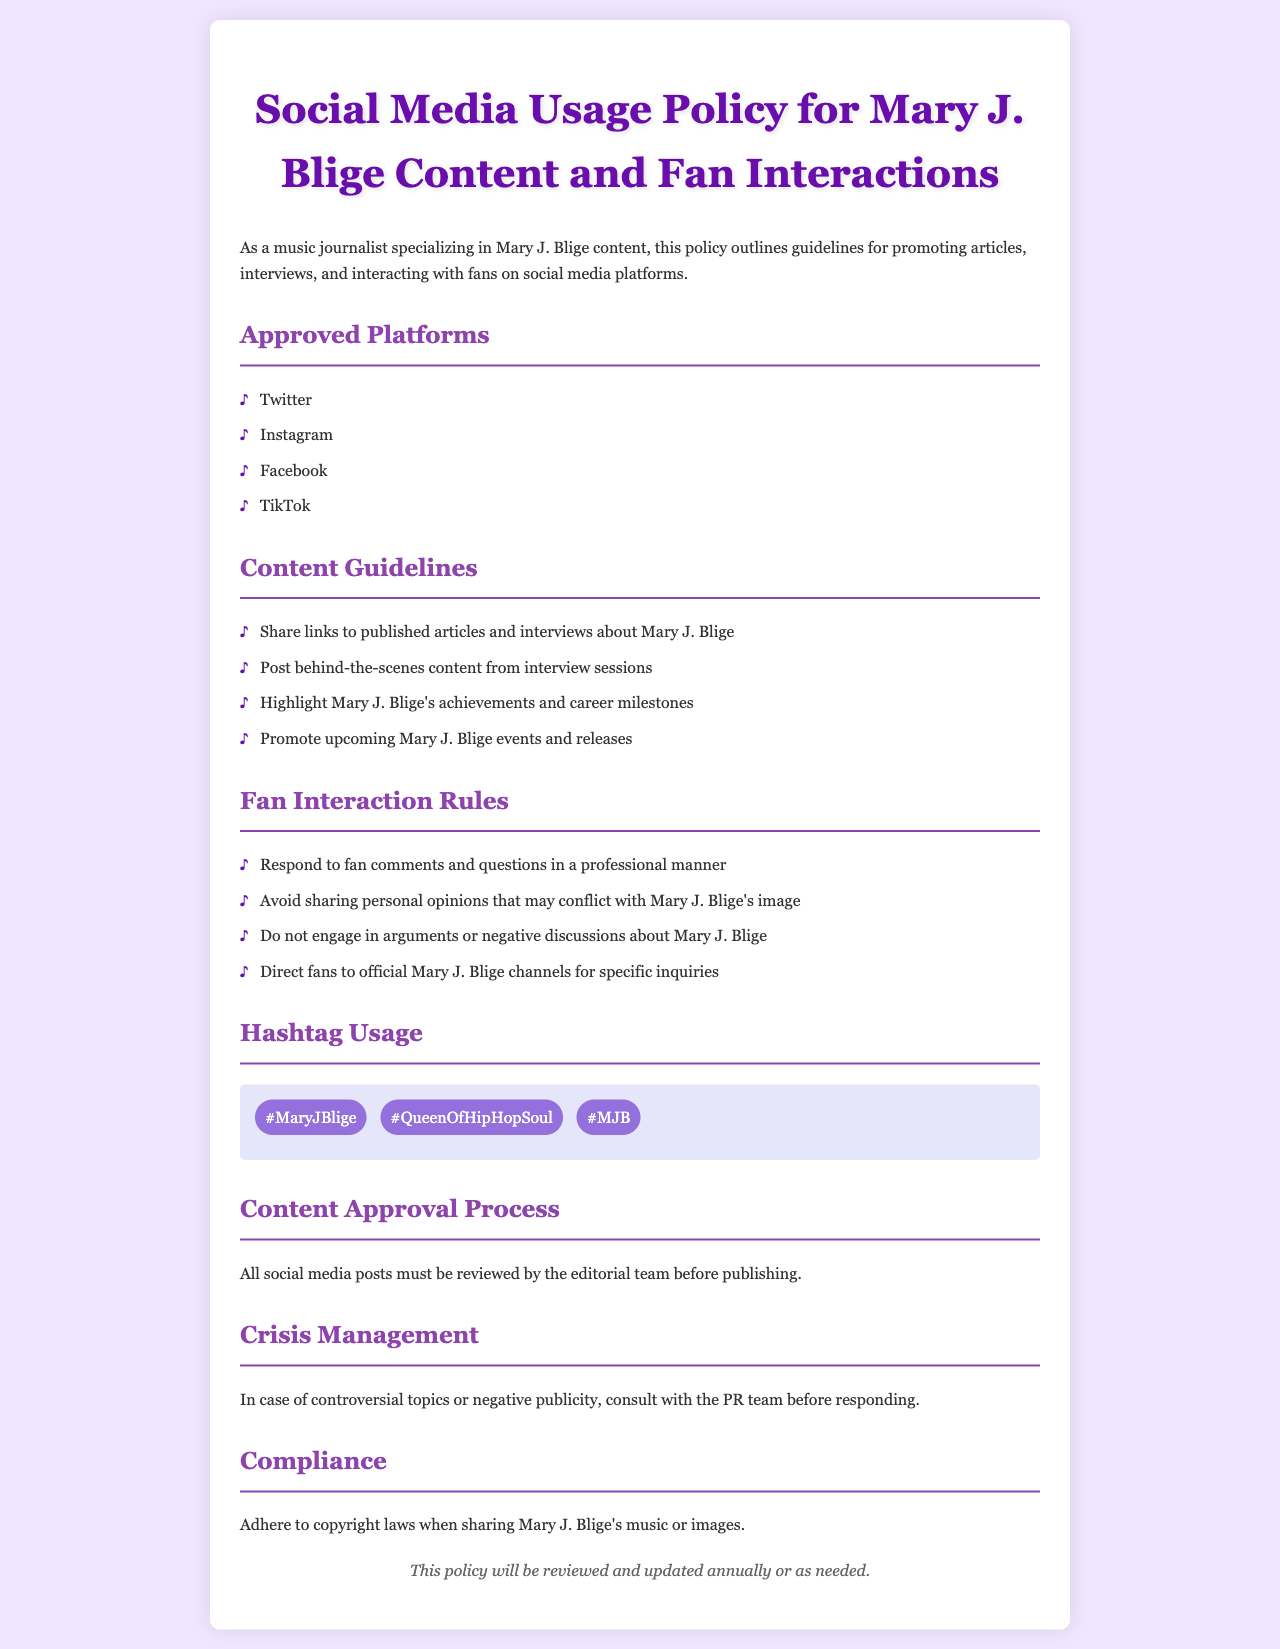What are the approved platforms for promoting Mary J. Blige content? The approved platforms are listed under "Approved Platforms" in the document.
Answer: Twitter, Instagram, Facebook, TikTok What is one of the content guidelines listed? The document specifies several content guidelines under "Content Guidelines."
Answer: Share links to published articles and interviews about Mary J. Blige What should be avoided in fan interactions? The document outlines rules under "Fan Interaction Rules" which includes things to avoid in interactions.
Answer: Engaging in arguments or negative discussions about Mary J. Blige What is the hashtag for Mary J. Blige? The document lists hashtags under "Hashtag Usage."
Answer: #MaryJBlige Who must review social media posts before publishing? The document mentions the reviewing party under "Content Approval Process."
Answer: Editorial team 